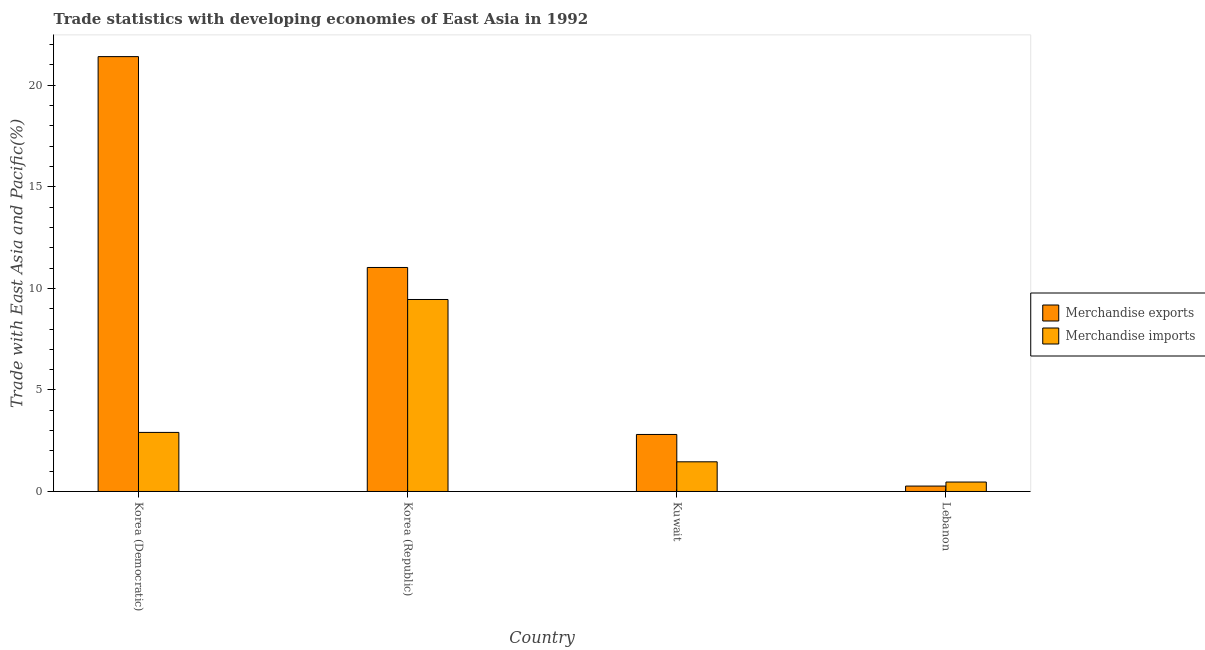How many different coloured bars are there?
Your answer should be very brief. 2. How many groups of bars are there?
Offer a terse response. 4. Are the number of bars on each tick of the X-axis equal?
Offer a very short reply. Yes. How many bars are there on the 3rd tick from the left?
Your answer should be very brief. 2. What is the label of the 1st group of bars from the left?
Your answer should be compact. Korea (Democratic). What is the merchandise imports in Lebanon?
Provide a short and direct response. 0.46. Across all countries, what is the maximum merchandise exports?
Ensure brevity in your answer.  21.41. Across all countries, what is the minimum merchandise exports?
Your answer should be compact. 0.27. In which country was the merchandise exports maximum?
Ensure brevity in your answer.  Korea (Democratic). In which country was the merchandise exports minimum?
Offer a very short reply. Lebanon. What is the total merchandise imports in the graph?
Your answer should be very brief. 14.29. What is the difference between the merchandise exports in Korea (Democratic) and that in Kuwait?
Your answer should be compact. 18.6. What is the difference between the merchandise imports in Korea (Democratic) and the merchandise exports in Lebanon?
Give a very brief answer. 2.64. What is the average merchandise exports per country?
Your answer should be compact. 8.88. What is the difference between the merchandise imports and merchandise exports in Korea (Republic)?
Offer a terse response. -1.58. In how many countries, is the merchandise exports greater than 20 %?
Your answer should be very brief. 1. What is the ratio of the merchandise exports in Korea (Democratic) to that in Korea (Republic)?
Provide a short and direct response. 1.94. What is the difference between the highest and the second highest merchandise exports?
Ensure brevity in your answer.  10.38. What is the difference between the highest and the lowest merchandise imports?
Offer a terse response. 8.99. In how many countries, is the merchandise exports greater than the average merchandise exports taken over all countries?
Give a very brief answer. 2. Is the sum of the merchandise exports in Korea (Republic) and Lebanon greater than the maximum merchandise imports across all countries?
Your answer should be very brief. Yes. What does the 2nd bar from the right in Lebanon represents?
Provide a succinct answer. Merchandise exports. How many bars are there?
Keep it short and to the point. 8. What is the difference between two consecutive major ticks on the Y-axis?
Your answer should be compact. 5. Are the values on the major ticks of Y-axis written in scientific E-notation?
Ensure brevity in your answer.  No. Where does the legend appear in the graph?
Make the answer very short. Center right. How many legend labels are there?
Provide a succinct answer. 2. What is the title of the graph?
Offer a terse response. Trade statistics with developing economies of East Asia in 1992. Does "Mobile cellular" appear as one of the legend labels in the graph?
Ensure brevity in your answer.  No. What is the label or title of the Y-axis?
Keep it short and to the point. Trade with East Asia and Pacific(%). What is the Trade with East Asia and Pacific(%) of Merchandise exports in Korea (Democratic)?
Ensure brevity in your answer.  21.41. What is the Trade with East Asia and Pacific(%) of Merchandise imports in Korea (Democratic)?
Ensure brevity in your answer.  2.91. What is the Trade with East Asia and Pacific(%) of Merchandise exports in Korea (Republic)?
Offer a terse response. 11.03. What is the Trade with East Asia and Pacific(%) of Merchandise imports in Korea (Republic)?
Your answer should be compact. 9.45. What is the Trade with East Asia and Pacific(%) in Merchandise exports in Kuwait?
Keep it short and to the point. 2.81. What is the Trade with East Asia and Pacific(%) in Merchandise imports in Kuwait?
Your answer should be very brief. 1.46. What is the Trade with East Asia and Pacific(%) of Merchandise exports in Lebanon?
Keep it short and to the point. 0.27. What is the Trade with East Asia and Pacific(%) of Merchandise imports in Lebanon?
Give a very brief answer. 0.46. Across all countries, what is the maximum Trade with East Asia and Pacific(%) in Merchandise exports?
Ensure brevity in your answer.  21.41. Across all countries, what is the maximum Trade with East Asia and Pacific(%) in Merchandise imports?
Make the answer very short. 9.45. Across all countries, what is the minimum Trade with East Asia and Pacific(%) of Merchandise exports?
Provide a succinct answer. 0.27. Across all countries, what is the minimum Trade with East Asia and Pacific(%) of Merchandise imports?
Give a very brief answer. 0.46. What is the total Trade with East Asia and Pacific(%) of Merchandise exports in the graph?
Offer a terse response. 35.51. What is the total Trade with East Asia and Pacific(%) of Merchandise imports in the graph?
Your answer should be very brief. 14.29. What is the difference between the Trade with East Asia and Pacific(%) of Merchandise exports in Korea (Democratic) and that in Korea (Republic)?
Offer a very short reply. 10.38. What is the difference between the Trade with East Asia and Pacific(%) in Merchandise imports in Korea (Democratic) and that in Korea (Republic)?
Your answer should be very brief. -6.54. What is the difference between the Trade with East Asia and Pacific(%) of Merchandise exports in Korea (Democratic) and that in Kuwait?
Provide a succinct answer. 18.6. What is the difference between the Trade with East Asia and Pacific(%) in Merchandise imports in Korea (Democratic) and that in Kuwait?
Provide a succinct answer. 1.45. What is the difference between the Trade with East Asia and Pacific(%) of Merchandise exports in Korea (Democratic) and that in Lebanon?
Offer a very short reply. 21.15. What is the difference between the Trade with East Asia and Pacific(%) of Merchandise imports in Korea (Democratic) and that in Lebanon?
Keep it short and to the point. 2.44. What is the difference between the Trade with East Asia and Pacific(%) in Merchandise exports in Korea (Republic) and that in Kuwait?
Provide a short and direct response. 8.22. What is the difference between the Trade with East Asia and Pacific(%) in Merchandise imports in Korea (Republic) and that in Kuwait?
Your response must be concise. 7.99. What is the difference between the Trade with East Asia and Pacific(%) in Merchandise exports in Korea (Republic) and that in Lebanon?
Your response must be concise. 10.76. What is the difference between the Trade with East Asia and Pacific(%) in Merchandise imports in Korea (Republic) and that in Lebanon?
Make the answer very short. 8.99. What is the difference between the Trade with East Asia and Pacific(%) of Merchandise exports in Kuwait and that in Lebanon?
Provide a short and direct response. 2.54. What is the difference between the Trade with East Asia and Pacific(%) of Merchandise exports in Korea (Democratic) and the Trade with East Asia and Pacific(%) of Merchandise imports in Korea (Republic)?
Offer a terse response. 11.96. What is the difference between the Trade with East Asia and Pacific(%) of Merchandise exports in Korea (Democratic) and the Trade with East Asia and Pacific(%) of Merchandise imports in Kuwait?
Make the answer very short. 19.95. What is the difference between the Trade with East Asia and Pacific(%) in Merchandise exports in Korea (Democratic) and the Trade with East Asia and Pacific(%) in Merchandise imports in Lebanon?
Offer a terse response. 20.95. What is the difference between the Trade with East Asia and Pacific(%) of Merchandise exports in Korea (Republic) and the Trade with East Asia and Pacific(%) of Merchandise imports in Kuwait?
Offer a terse response. 9.57. What is the difference between the Trade with East Asia and Pacific(%) of Merchandise exports in Korea (Republic) and the Trade with East Asia and Pacific(%) of Merchandise imports in Lebanon?
Make the answer very short. 10.56. What is the difference between the Trade with East Asia and Pacific(%) of Merchandise exports in Kuwait and the Trade with East Asia and Pacific(%) of Merchandise imports in Lebanon?
Your response must be concise. 2.34. What is the average Trade with East Asia and Pacific(%) in Merchandise exports per country?
Your response must be concise. 8.88. What is the average Trade with East Asia and Pacific(%) in Merchandise imports per country?
Your answer should be very brief. 3.57. What is the difference between the Trade with East Asia and Pacific(%) in Merchandise exports and Trade with East Asia and Pacific(%) in Merchandise imports in Korea (Democratic)?
Give a very brief answer. 18.5. What is the difference between the Trade with East Asia and Pacific(%) of Merchandise exports and Trade with East Asia and Pacific(%) of Merchandise imports in Korea (Republic)?
Your response must be concise. 1.58. What is the difference between the Trade with East Asia and Pacific(%) of Merchandise exports and Trade with East Asia and Pacific(%) of Merchandise imports in Kuwait?
Your answer should be very brief. 1.35. What is the difference between the Trade with East Asia and Pacific(%) of Merchandise exports and Trade with East Asia and Pacific(%) of Merchandise imports in Lebanon?
Your response must be concise. -0.2. What is the ratio of the Trade with East Asia and Pacific(%) in Merchandise exports in Korea (Democratic) to that in Korea (Republic)?
Give a very brief answer. 1.94. What is the ratio of the Trade with East Asia and Pacific(%) of Merchandise imports in Korea (Democratic) to that in Korea (Republic)?
Your response must be concise. 0.31. What is the ratio of the Trade with East Asia and Pacific(%) of Merchandise exports in Korea (Democratic) to that in Kuwait?
Ensure brevity in your answer.  7.63. What is the ratio of the Trade with East Asia and Pacific(%) of Merchandise imports in Korea (Democratic) to that in Kuwait?
Your answer should be very brief. 1.99. What is the ratio of the Trade with East Asia and Pacific(%) of Merchandise exports in Korea (Democratic) to that in Lebanon?
Keep it short and to the point. 80.34. What is the ratio of the Trade with East Asia and Pacific(%) of Merchandise imports in Korea (Democratic) to that in Lebanon?
Give a very brief answer. 6.26. What is the ratio of the Trade with East Asia and Pacific(%) in Merchandise exports in Korea (Republic) to that in Kuwait?
Make the answer very short. 3.93. What is the ratio of the Trade with East Asia and Pacific(%) in Merchandise imports in Korea (Republic) to that in Kuwait?
Provide a succinct answer. 6.47. What is the ratio of the Trade with East Asia and Pacific(%) in Merchandise exports in Korea (Republic) to that in Lebanon?
Your answer should be compact. 41.38. What is the ratio of the Trade with East Asia and Pacific(%) of Merchandise imports in Korea (Republic) to that in Lebanon?
Make the answer very short. 20.34. What is the ratio of the Trade with East Asia and Pacific(%) in Merchandise exports in Kuwait to that in Lebanon?
Your answer should be very brief. 10.53. What is the ratio of the Trade with East Asia and Pacific(%) in Merchandise imports in Kuwait to that in Lebanon?
Your answer should be very brief. 3.14. What is the difference between the highest and the second highest Trade with East Asia and Pacific(%) in Merchandise exports?
Your answer should be very brief. 10.38. What is the difference between the highest and the second highest Trade with East Asia and Pacific(%) of Merchandise imports?
Make the answer very short. 6.54. What is the difference between the highest and the lowest Trade with East Asia and Pacific(%) of Merchandise exports?
Ensure brevity in your answer.  21.15. What is the difference between the highest and the lowest Trade with East Asia and Pacific(%) in Merchandise imports?
Ensure brevity in your answer.  8.99. 